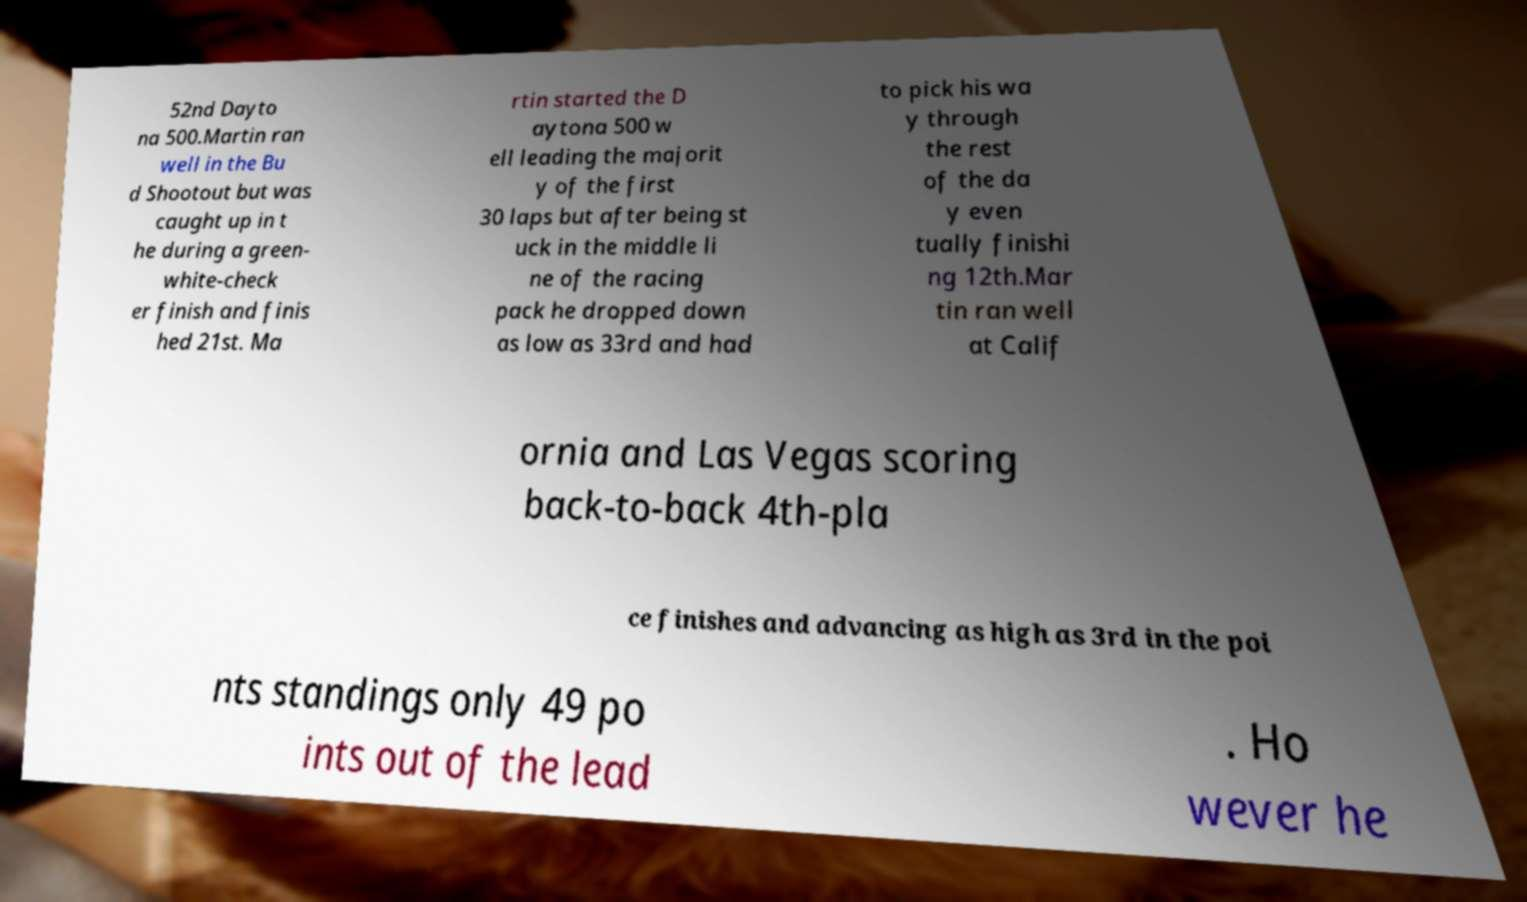What messages or text are displayed in this image? I need them in a readable, typed format. 52nd Dayto na 500.Martin ran well in the Bu d Shootout but was caught up in t he during a green- white-check er finish and finis hed 21st. Ma rtin started the D aytona 500 w ell leading the majorit y of the first 30 laps but after being st uck in the middle li ne of the racing pack he dropped down as low as 33rd and had to pick his wa y through the rest of the da y even tually finishi ng 12th.Mar tin ran well at Calif ornia and Las Vegas scoring back-to-back 4th-pla ce finishes and advancing as high as 3rd in the poi nts standings only 49 po ints out of the lead . Ho wever he 